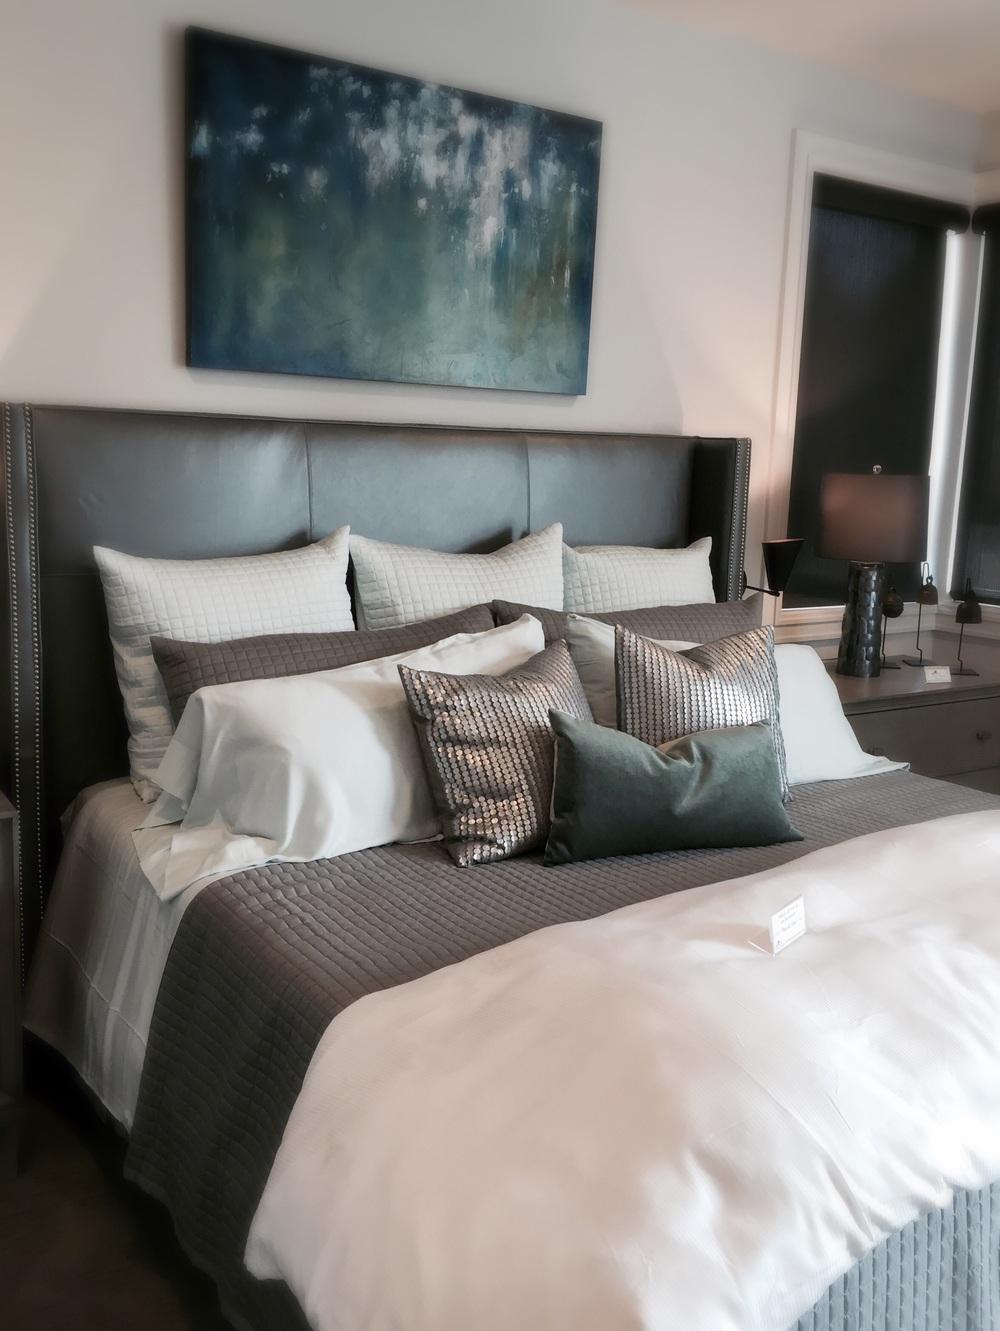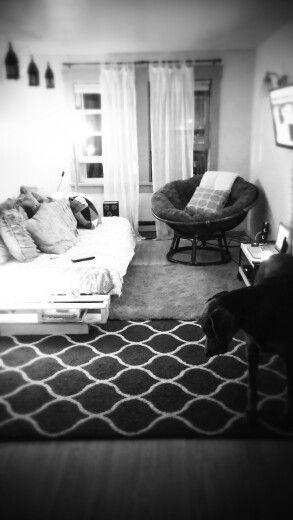The first image is the image on the left, the second image is the image on the right. For the images shown, is this caption "there is a table lamp on the right image" true? Answer yes or no. No. 